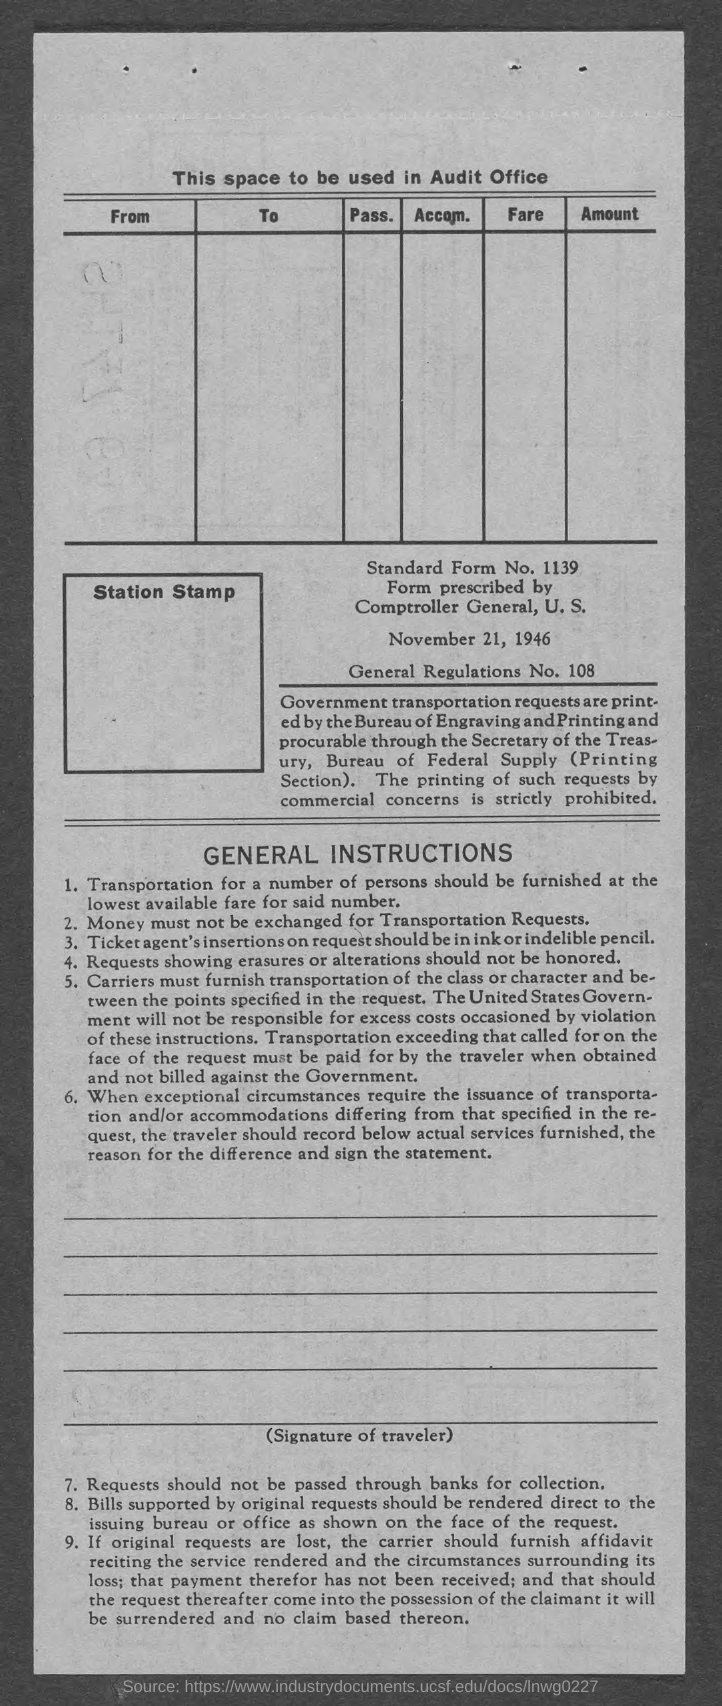What is the Standard Form No. given in the document?
Ensure brevity in your answer.  1139. What is the date mentioned in this document?
Ensure brevity in your answer.  November 21, 1946. What is the General Regulations No. given in the document?
Your response must be concise. 108. 